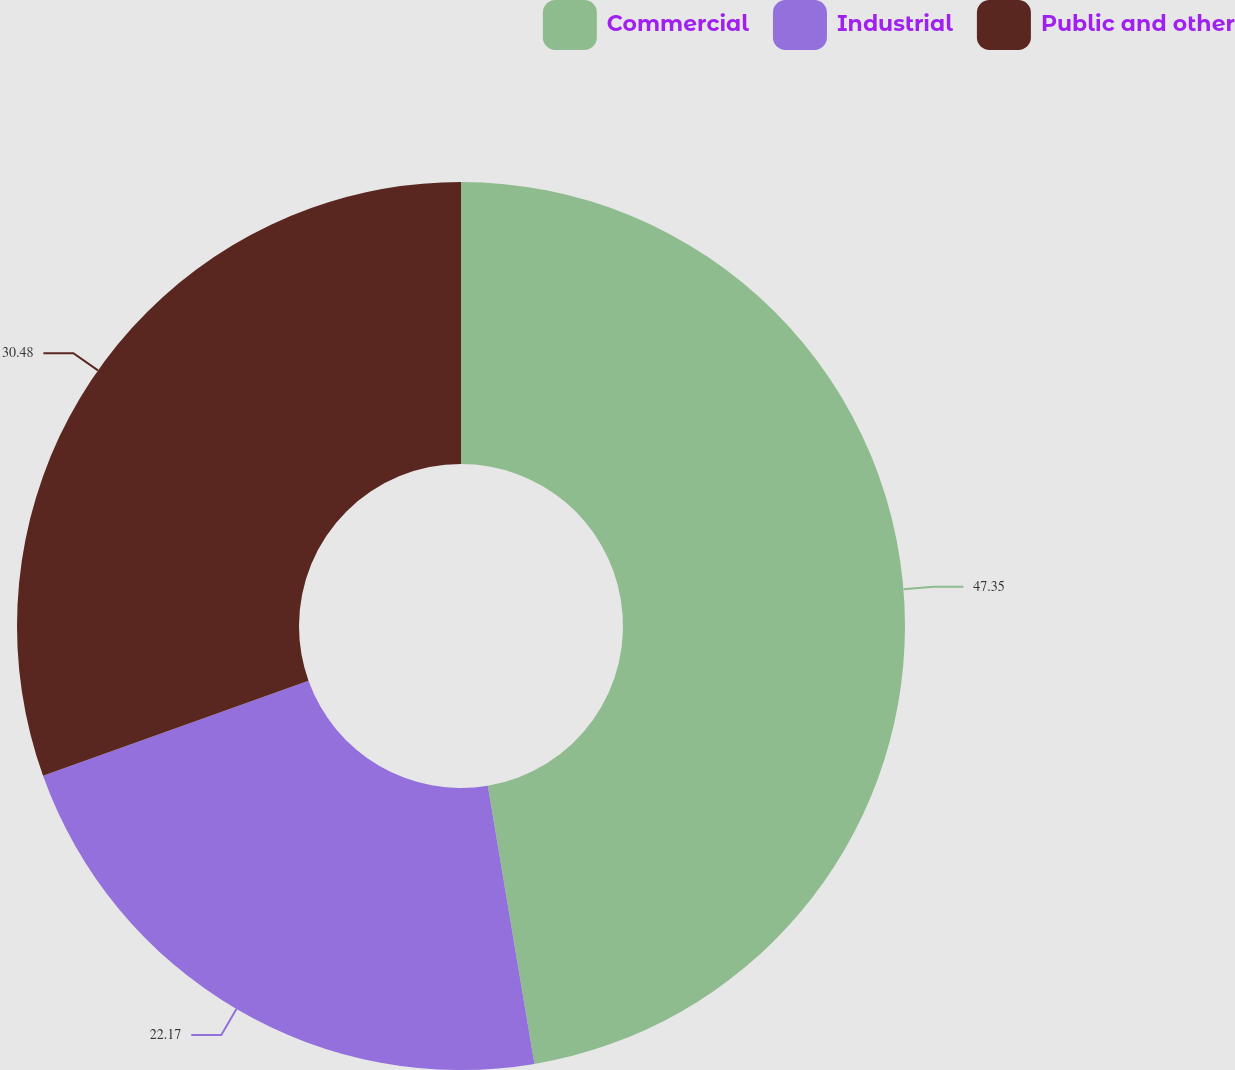Convert chart. <chart><loc_0><loc_0><loc_500><loc_500><pie_chart><fcel>Commercial<fcel>Industrial<fcel>Public and other<nl><fcel>47.36%<fcel>22.17%<fcel>30.48%<nl></chart> 